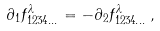Convert formula to latex. <formula><loc_0><loc_0><loc_500><loc_500>\partial _ { 1 } f _ { 1 2 3 4 \dots } ^ { \lambda } = - \partial _ { 2 } f _ { 1 2 3 4 \dots } ^ { \lambda } \, ,</formula> 